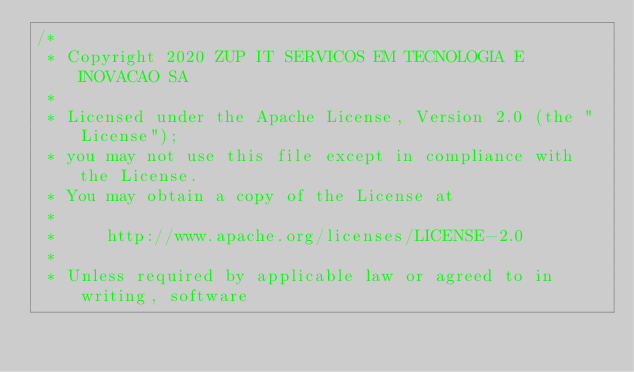Convert code to text. <code><loc_0><loc_0><loc_500><loc_500><_Kotlin_>/*
 * Copyright 2020 ZUP IT SERVICOS EM TECNOLOGIA E INOVACAO SA
 *
 * Licensed under the Apache License, Version 2.0 (the "License");
 * you may not use this file except in compliance with the License.
 * You may obtain a copy of the License at
 *
 *     http://www.apache.org/licenses/LICENSE-2.0
 *
 * Unless required by applicable law or agreed to in writing, software</code> 